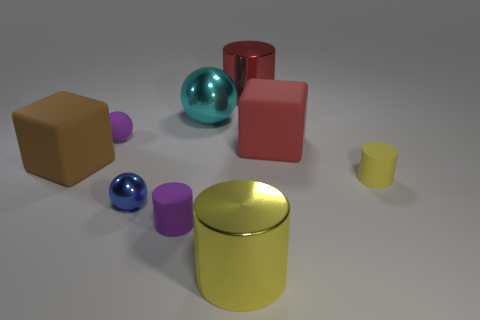Looking at the scene, what concepts could be illustrated here? The image could be illustrating several concepts. One is the study of geometry, showcasing the fundamental shapes like cubes, spheres, and cylinders. Another concept could be material properties and how light interacts with different surfaces, demonstrated by the varying levels of reflection and texture. This setup could also be used to discuss color theory with the range of colors presented, or even used as a simple counting exercise for educational purposes. 